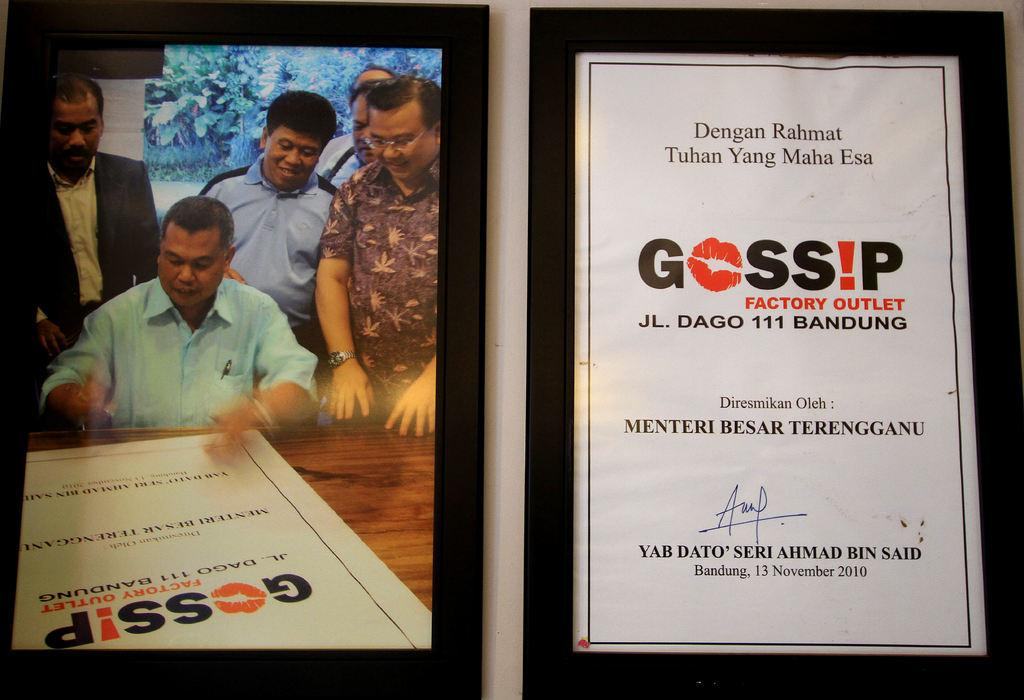<image>
Create a compact narrative representing the image presented. A man signing a large Gossip factory outlet poster 